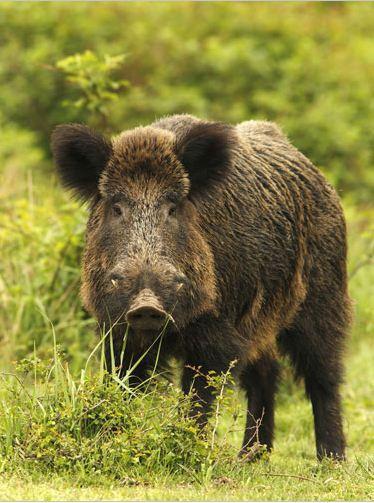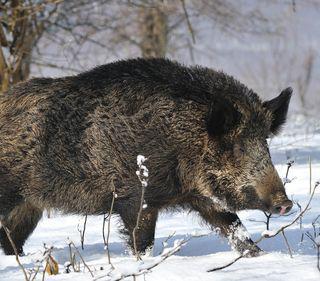The first image is the image on the left, the second image is the image on the right. Assess this claim about the two images: "An image contains a single boar wading through water.". Correct or not? Answer yes or no. No. The first image is the image on the left, the second image is the image on the right. Given the left and right images, does the statement "One image shows a wild pig wading in brown water" hold true? Answer yes or no. No. 